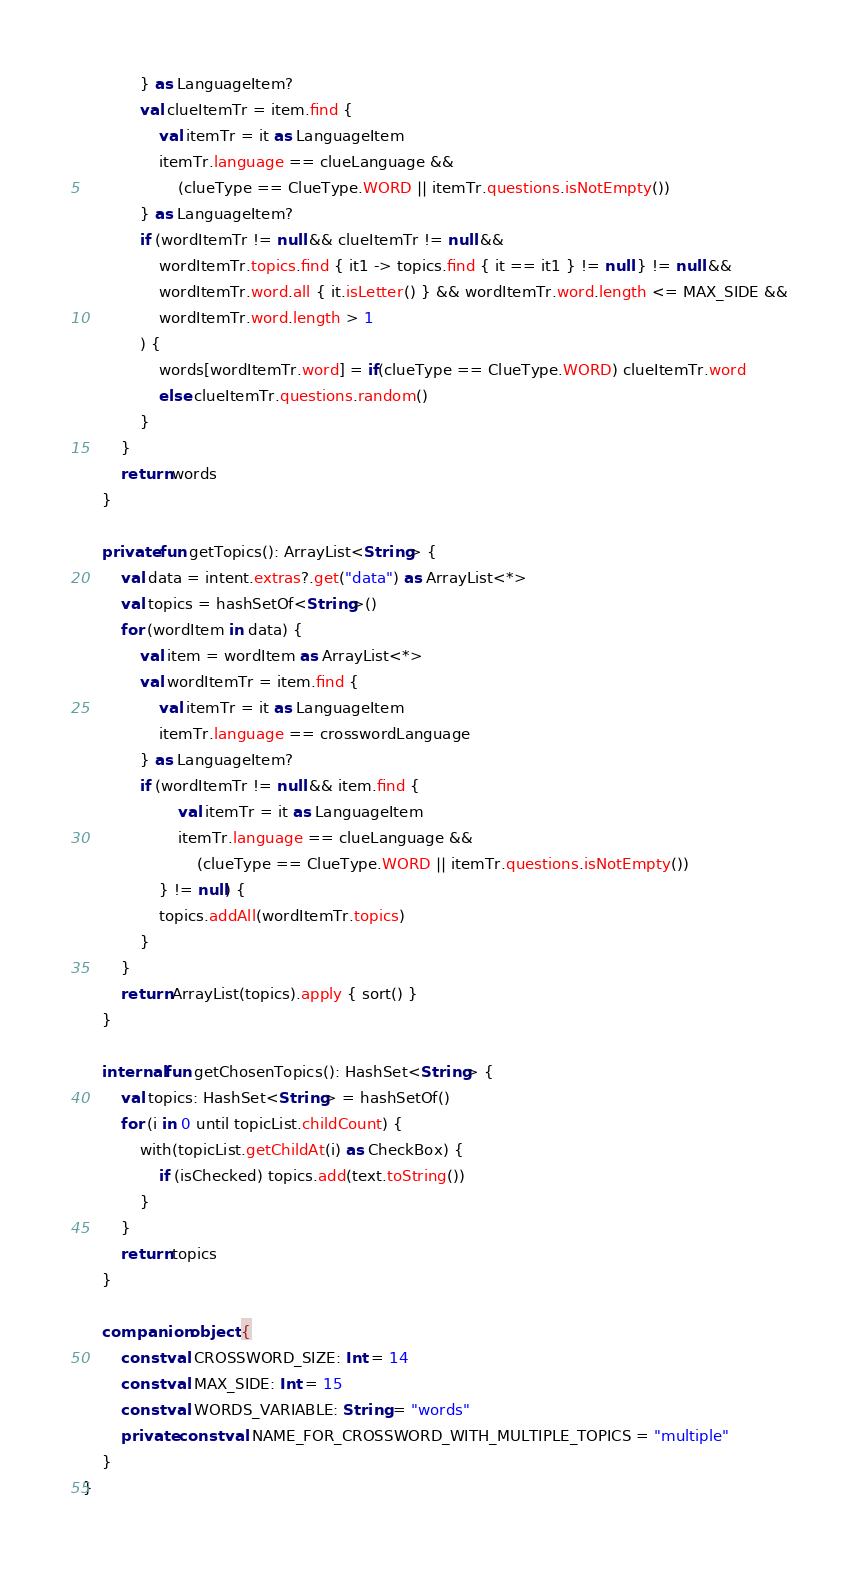<code> <loc_0><loc_0><loc_500><loc_500><_Kotlin_>            } as LanguageItem?
            val clueItemTr = item.find {
                val itemTr = it as LanguageItem
                itemTr.language == clueLanguage &&
                    (clueType == ClueType.WORD || itemTr.questions.isNotEmpty())
            } as LanguageItem?
            if (wordItemTr != null && clueItemTr != null &&
                wordItemTr.topics.find { it1 -> topics.find { it == it1 } != null } != null &&
                wordItemTr.word.all { it.isLetter() } && wordItemTr.word.length <= MAX_SIDE &&
                wordItemTr.word.length > 1
            ) {
                words[wordItemTr.word] = if(clueType == ClueType.WORD) clueItemTr.word
                else clueItemTr.questions.random()
            }
        }
        return words
    }

    private fun getTopics(): ArrayList<String> {
        val data = intent.extras?.get("data") as ArrayList<*>
        val topics = hashSetOf<String>()
        for (wordItem in data) {
            val item = wordItem as ArrayList<*>
            val wordItemTr = item.find {
                val itemTr = it as LanguageItem
                itemTr.language == crosswordLanguage
            } as LanguageItem?
            if (wordItemTr != null && item.find {
                    val itemTr = it as LanguageItem
                    itemTr.language == clueLanguage &&
                        (clueType == ClueType.WORD || itemTr.questions.isNotEmpty())
                } != null) {
                topics.addAll(wordItemTr.topics)
            }
        }
        return ArrayList(topics).apply { sort() }
    }

    internal fun getChosenTopics(): HashSet<String> {
        val topics: HashSet<String> = hashSetOf()
        for (i in 0 until topicList.childCount) {
            with(topicList.getChildAt(i) as CheckBox) {
                if (isChecked) topics.add(text.toString())
            }
        }
        return topics
    }

    companion object {
        const val CROSSWORD_SIZE: Int = 14
        const val MAX_SIDE: Int = 15
        const val WORDS_VARIABLE: String = "words"
        private const val NAME_FOR_CROSSWORD_WITH_MULTIPLE_TOPICS = "multiple"
    }
}
</code> 